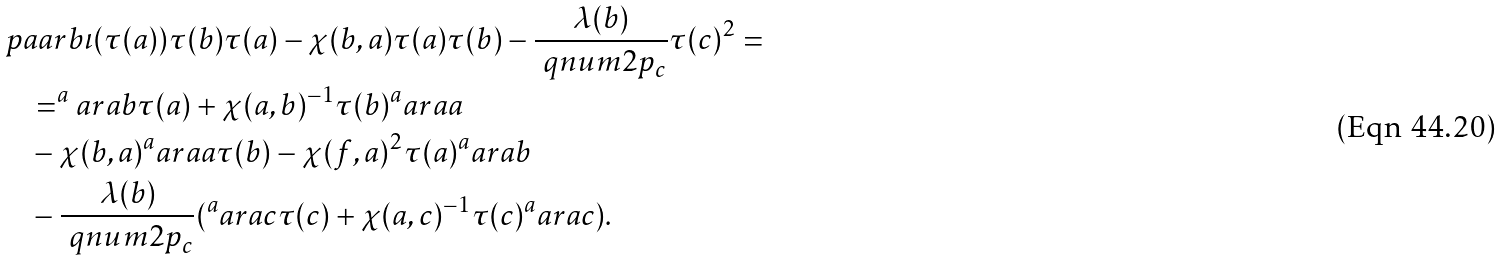Convert formula to latex. <formula><loc_0><loc_0><loc_500><loc_500>& \ p a a r b { \iota ( \tau ( a ) ) } { \tau ( b ) \tau ( a ) - \chi ( b , a ) \tau ( a ) \tau ( b ) - \frac { \lambda ( b ) } { \ q n u m { 2 } { p _ { c } } } \tau ( c ) ^ { 2 } } = \\ & \quad = ^ { a } a r { a } { b } \tau ( a ) + \chi ( a , b ) ^ { - 1 } \tau ( b ) ^ { a } a r { a } { a } \\ & \quad - \chi ( b , a ) ^ { a } a r { a } { a } \tau ( b ) - \chi ( f , a ) ^ { 2 } \tau ( a ) ^ { a } a r { a } { b } \\ & \quad - \frac { \lambda ( b ) } { \ q n u m { 2 } { p _ { c } } } ( ^ { a } a r { a } { c } \tau ( c ) + \chi ( a , c ) ^ { - 1 } \tau ( c ) ^ { a } a r { a } { c } ) .</formula> 